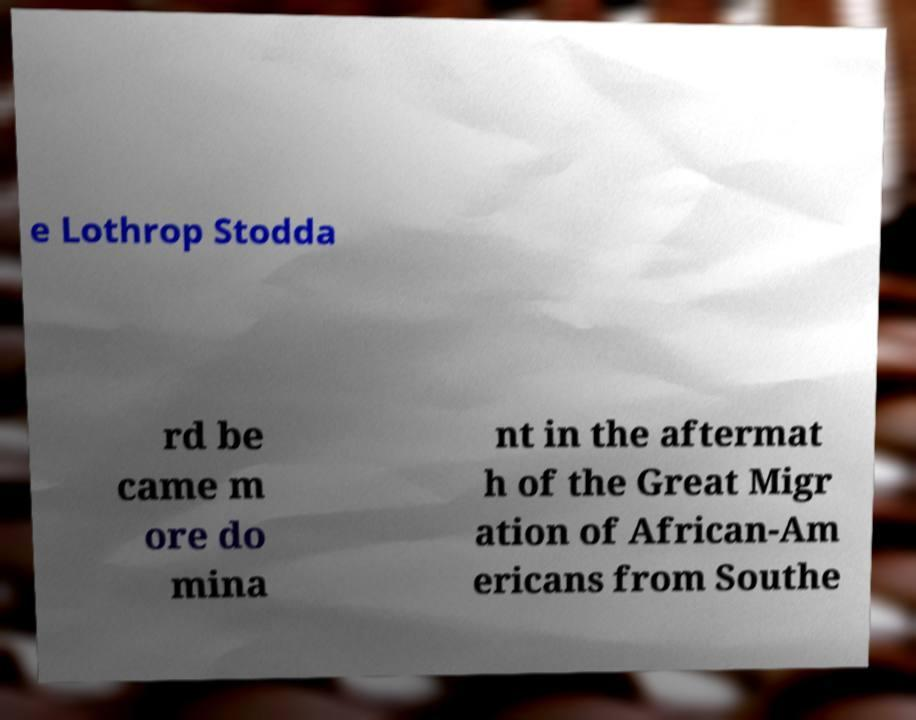For documentation purposes, I need the text within this image transcribed. Could you provide that? e Lothrop Stodda rd be came m ore do mina nt in the aftermat h of the Great Migr ation of African-Am ericans from Southe 